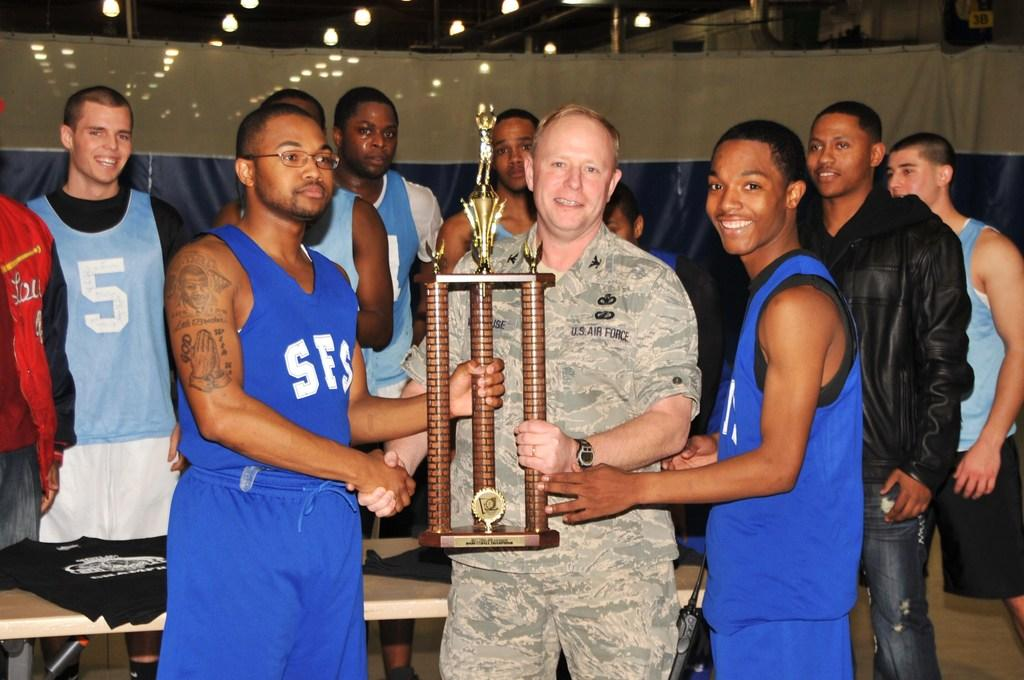<image>
Give a short and clear explanation of the subsequent image. Player number 5 in the light blue shirt in the back row is smiling for the group photo. 